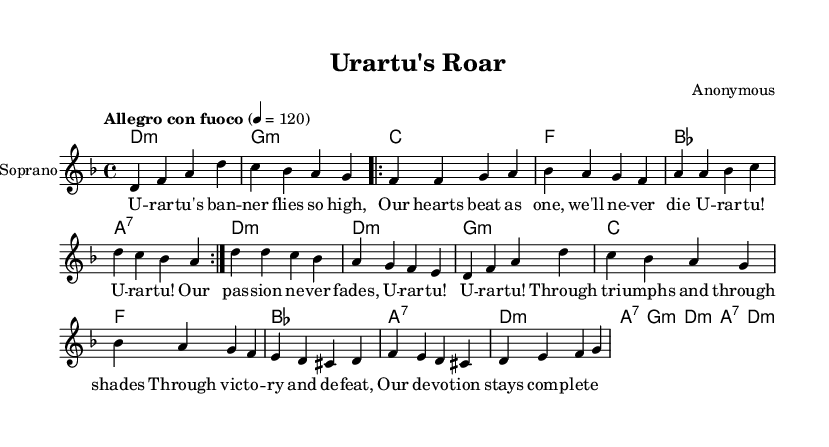What is the key signature of this music? The key signature indicated at the beginning of the score shows two flats, which correspond to the key of D minor.
Answer: D minor What is the time signature of this music? The time signature shown at the beginning of the sheet music is 4/4, indicating four beats per measure.
Answer: 4/4 What is the tempo marking of this music? The tempo marking in the score specifies "Allegro con fuoco," indicating a brisk and fiery tempo, set at 120 beats per minute.
Answer: Allegro con fuoco How many verses are there in this piece? By looking at the structure, the lyrics indicate that there is one verse section repeated two times before the chorus.
Answer: 1 What does the bridge signify in opera? The bridge typically serves as a contrasting section in opera, often providing emotional depth or a narrative shift; in this piece, it captures the unwavering devotion of the fans.
Answer: Emotional depth What emotion does the chorus express in this opera? The chorus section captures the passionate loyalty of the fans, celebrating their enduring spirit through triumphs and trials, which is a common theme in operatic narratives.
Answer: Passionate loyalty What is the overall theme of this dramatic opera? The opera depicts the fervent loyalty and collective spirit of sports fans, illustrating the highs and lows of their experiences, akin to the dramatic arcs found in traditional operas.
Answer: Loyalty of sports fans 